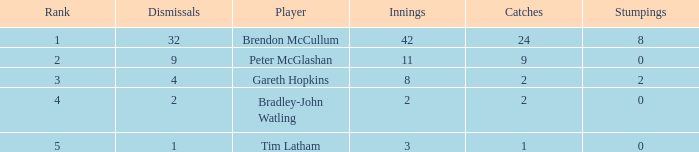List the ranks of all dismissals with a value of 4 3.0. I'm looking to parse the entire table for insights. Could you assist me with that? {'header': ['Rank', 'Dismissals', 'Player', 'Innings', 'Catches', 'Stumpings'], 'rows': [['1', '32', 'Brendon McCullum', '42', '24', '8'], ['2', '9', 'Peter McGlashan', '11', '9', '0'], ['3', '4', 'Gareth Hopkins', '8', '2', '2'], ['4', '2', 'Bradley-John Watling', '2', '2', '0'], ['5', '1', 'Tim Latham', '3', '1', '0']]} 